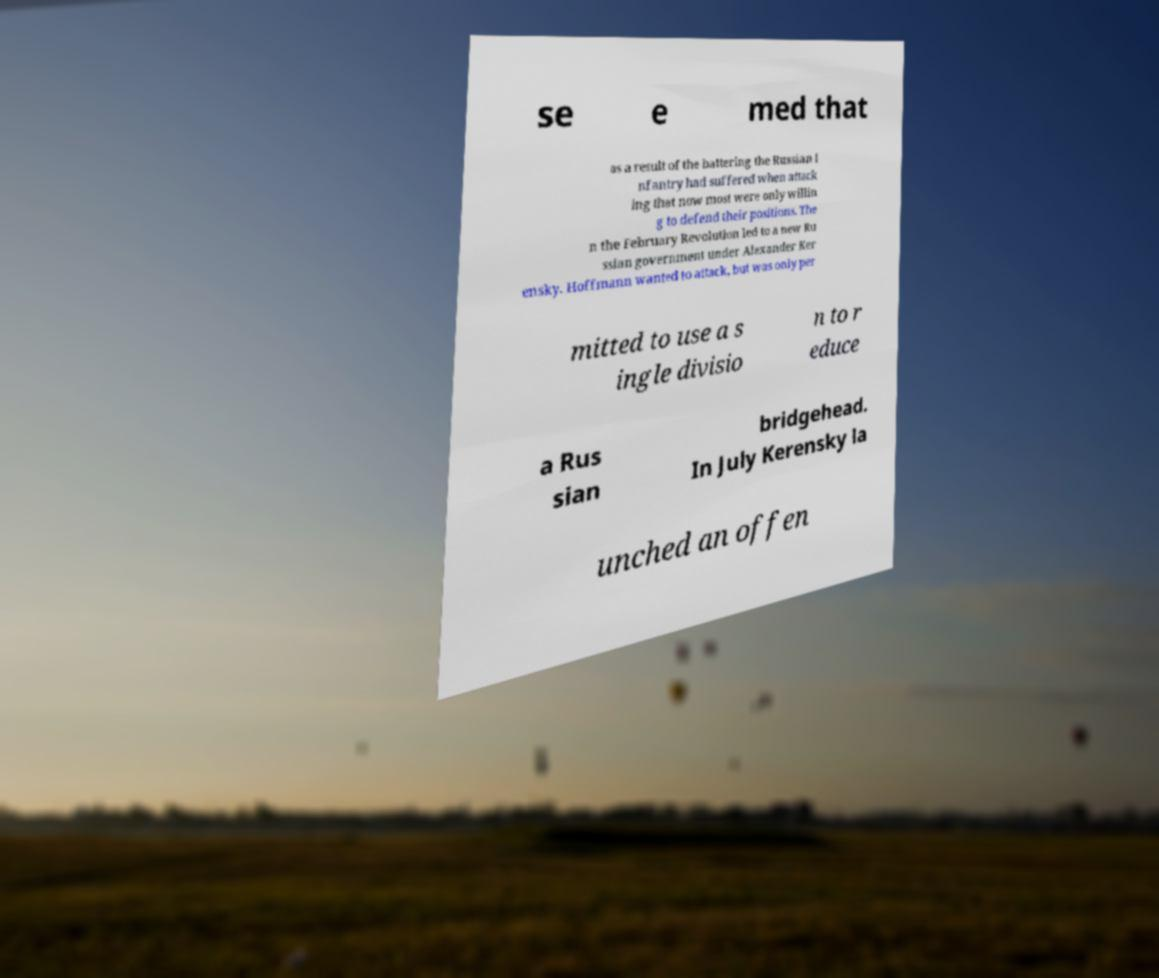Can you accurately transcribe the text from the provided image for me? se e med that as a result of the battering the Russian i nfantry had suffered when attack ing that now most were only willin g to defend their positions. The n the February Revolution led to a new Ru ssian government under Alexander Ker ensky. Hoffmann wanted to attack, but was only per mitted to use a s ingle divisio n to r educe a Rus sian bridgehead. In July Kerensky la unched an offen 